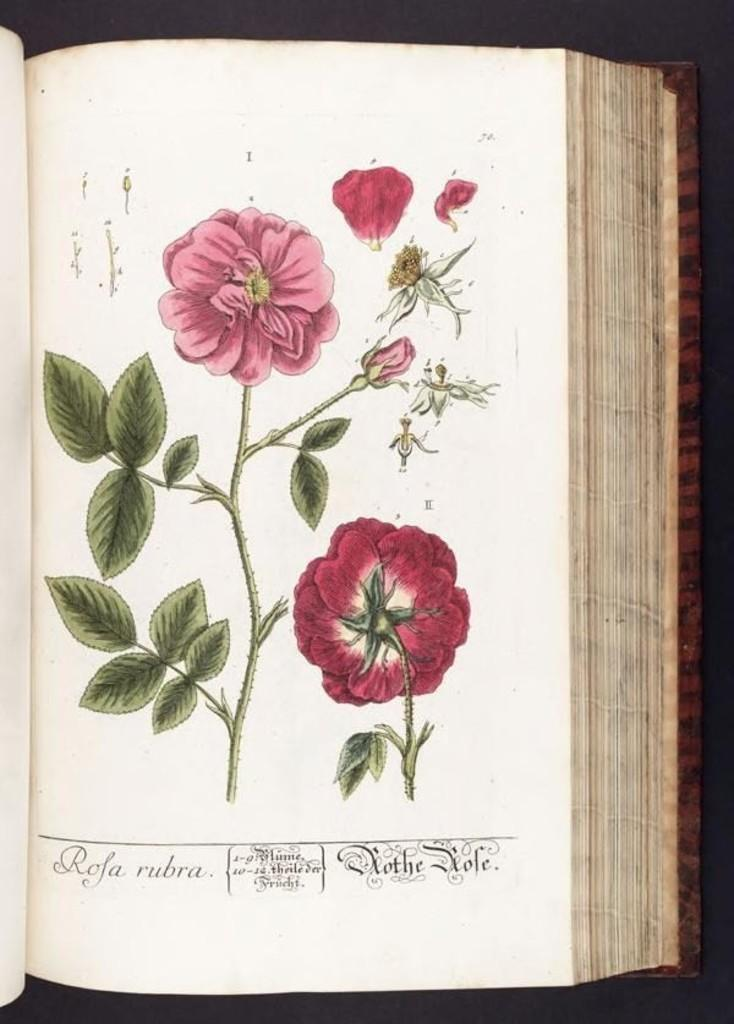What is the main subject of the image? The main subject of the image is a book. What type of content is inside the book? The paper within the book contains drawings of flowers, leaves, and stems. What type of guitar can be seen in the image? There is no guitar present in the image; it features a book with drawings of flowers, leaves, and stems. What type of muscle is depicted in the image? There is no muscle depicted in the image; it features a book with drawings of flowers, leaves, and stems. 